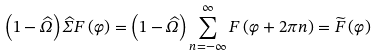Convert formula to latex. <formula><loc_0><loc_0><loc_500><loc_500>\left ( 1 - \widehat { \Omega } \right ) \widehat { \Sigma } F \left ( \varphi \right ) = \left ( 1 - \widehat { \Omega } \right ) \sum _ { n = - \infty } ^ { \infty } F \left ( \varphi + 2 \pi n \right ) = \widetilde { F } \left ( \varphi \right )</formula> 